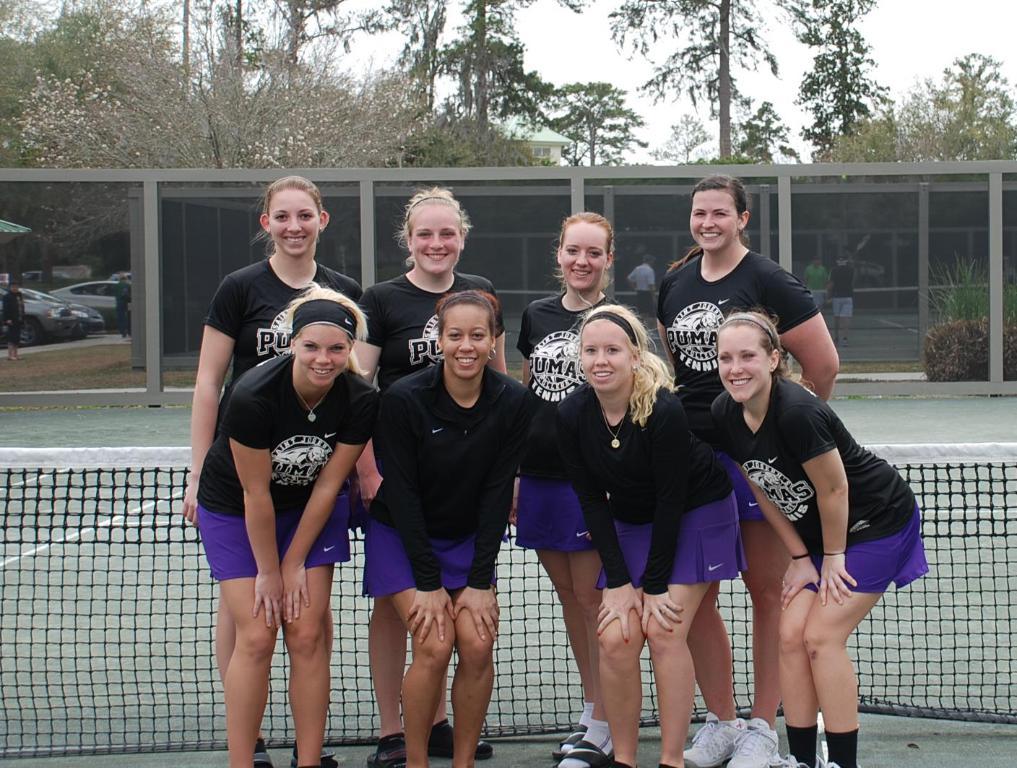What sport do the girls play?
Offer a terse response. Answering does not require reading text in the image. 